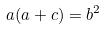<formula> <loc_0><loc_0><loc_500><loc_500>a ( a + c ) = b ^ { 2 }</formula> 